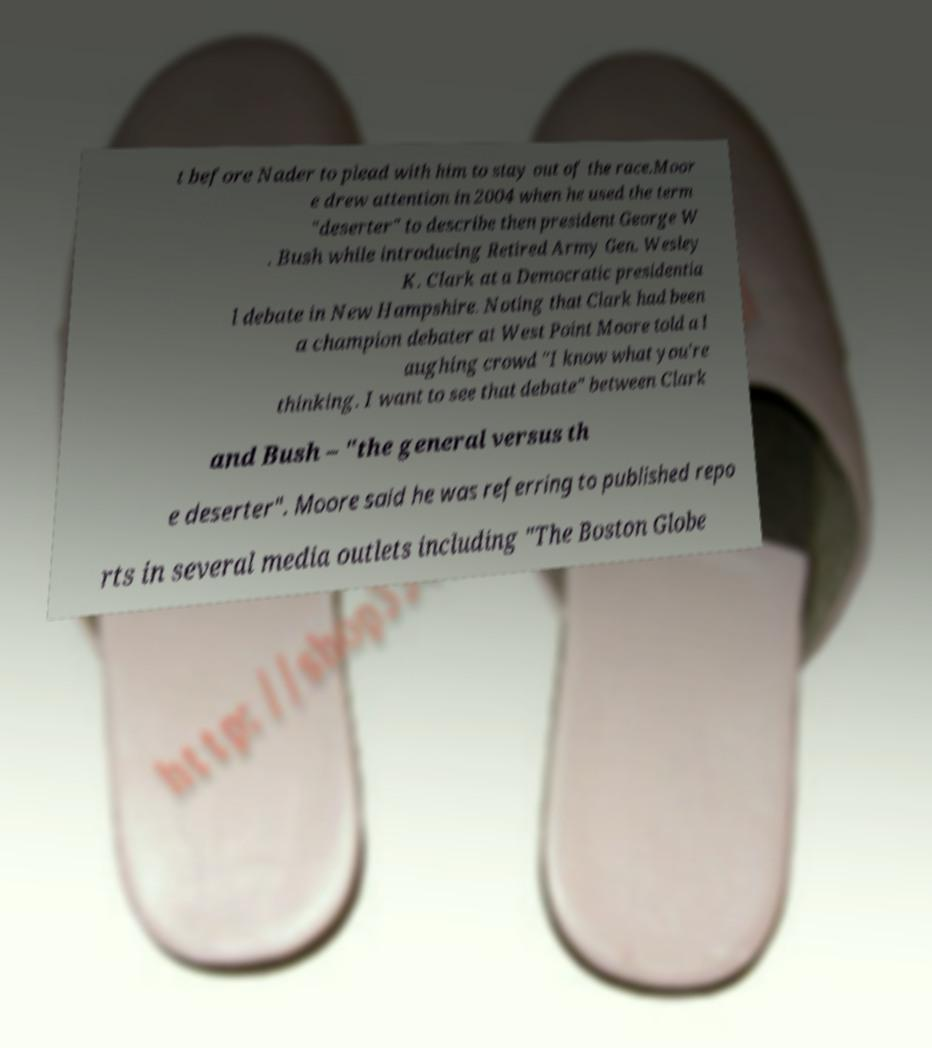Please identify and transcribe the text found in this image. t before Nader to plead with him to stay out of the race.Moor e drew attention in 2004 when he used the term "deserter" to describe then president George W . Bush while introducing Retired Army Gen. Wesley K. Clark at a Democratic presidentia l debate in New Hampshire. Noting that Clark had been a champion debater at West Point Moore told a l aughing crowd "I know what you're thinking. I want to see that debate" between Clark and Bush – "the general versus th e deserter". Moore said he was referring to published repo rts in several media outlets including "The Boston Globe 